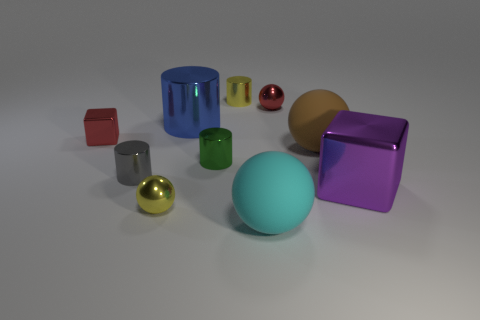Subtract 1 balls. How many balls are left? 3 Subtract all purple cylinders. Subtract all cyan blocks. How many cylinders are left? 4 Subtract all cubes. How many objects are left? 8 Subtract 1 red blocks. How many objects are left? 9 Subtract all big red cubes. Subtract all cubes. How many objects are left? 8 Add 7 tiny blocks. How many tiny blocks are left? 8 Add 6 tiny purple rubber spheres. How many tiny purple rubber spheres exist? 6 